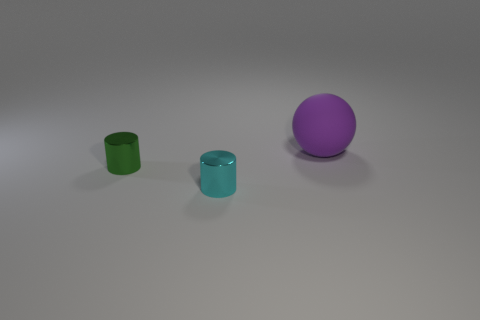Are there any other things that have the same size as the matte ball?
Offer a very short reply. No. How many things are both in front of the purple rubber ball and behind the cyan metal object?
Make the answer very short. 1. Are there more small green shiny things to the right of the green cylinder than small cyan cylinders that are on the right side of the big purple matte object?
Provide a succinct answer. No. What is the material of the small thing behind the small cyan shiny cylinder?
Give a very brief answer. Metal. Do the tiny green thing and the object in front of the small green thing have the same shape?
Make the answer very short. Yes. What number of large balls are behind the object that is on the left side of the tiny cyan thing that is on the right side of the green metallic object?
Your response must be concise. 1. The other tiny shiny object that is the same shape as the cyan shiny object is what color?
Offer a very short reply. Green. Are there any other things that are the same shape as the purple matte object?
Your answer should be compact. No. What number of spheres are either small purple metal objects or matte objects?
Provide a succinct answer. 1. What shape is the tiny cyan metal object?
Ensure brevity in your answer.  Cylinder. 